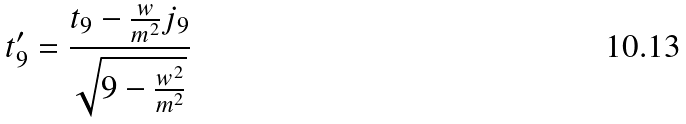Convert formula to latex. <formula><loc_0><loc_0><loc_500><loc_500>t _ { 9 } ^ { \prime } = \frac { t _ { 9 } - \frac { w } { m ^ { 2 } } j _ { 9 } } { \sqrt { 9 - \frac { w ^ { 2 } } { m ^ { 2 } } } }</formula> 